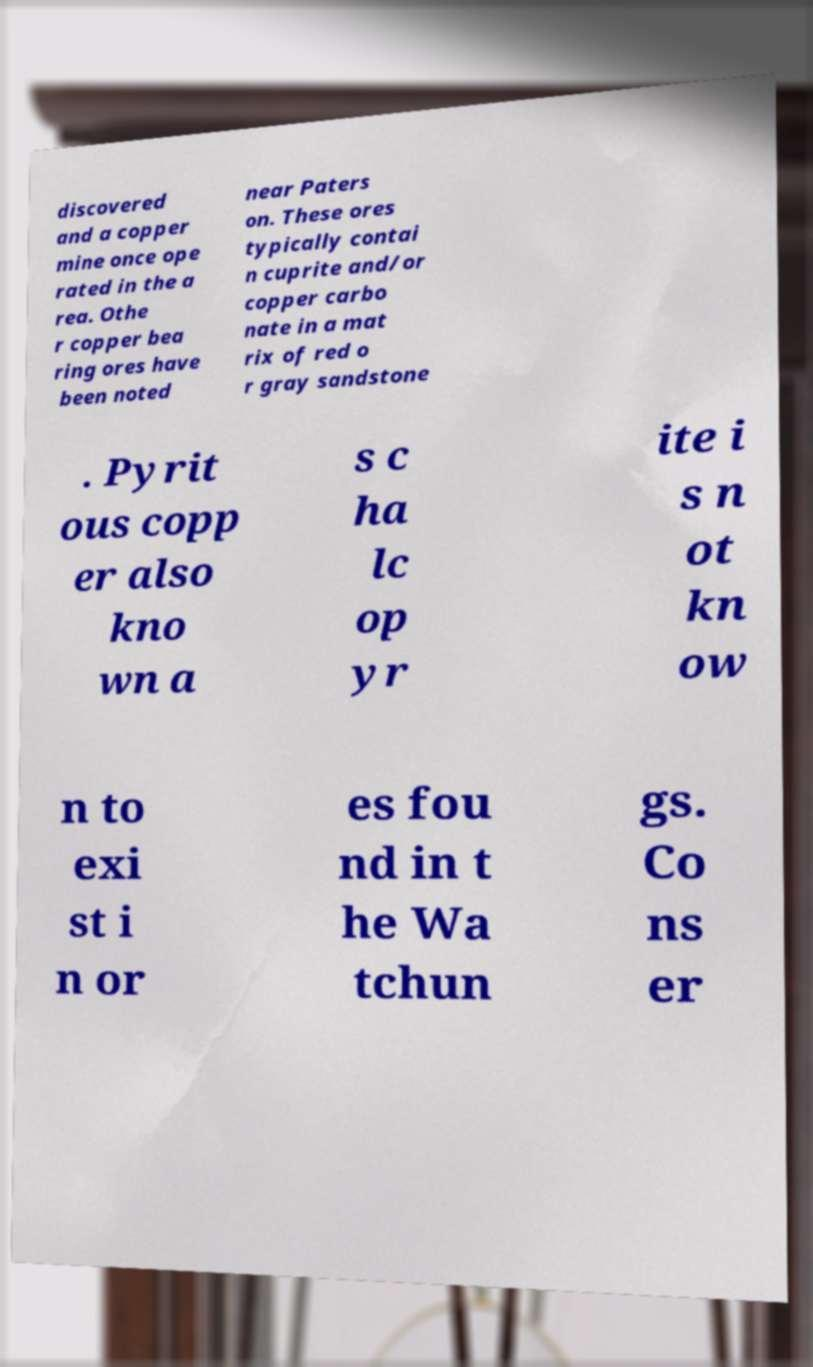I need the written content from this picture converted into text. Can you do that? discovered and a copper mine once ope rated in the a rea. Othe r copper bea ring ores have been noted near Paters on. These ores typically contai n cuprite and/or copper carbo nate in a mat rix of red o r gray sandstone . Pyrit ous copp er also kno wn a s c ha lc op yr ite i s n ot kn ow n to exi st i n or es fou nd in t he Wa tchun gs. Co ns er 